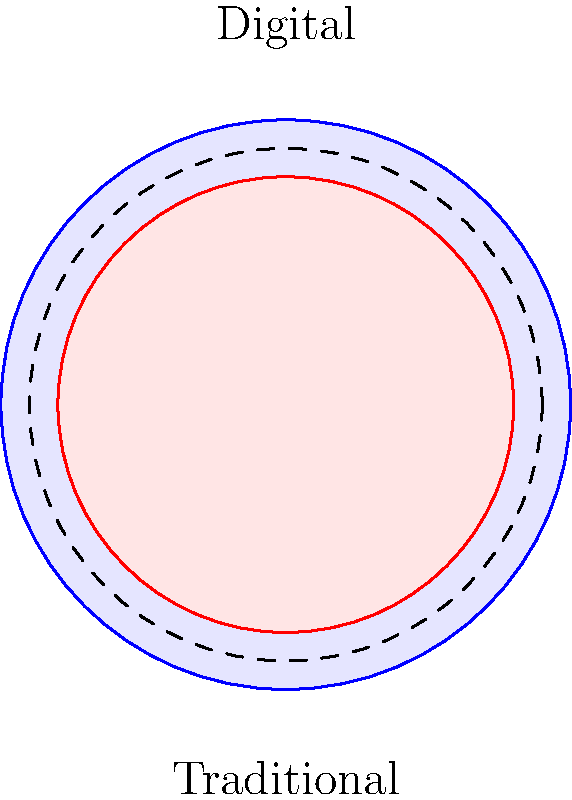Based on the color wheels shown in the diagram, which represents a larger color gamut: digital displays or traditional paint pigments? Explain the significance of this difference for digital artists. To answer this question, let's analyze the diagram and consider the implications for digital artists:

1. Observe the diagram: There are two concentric circles representing color wheels.
   - The outer, larger circle (blue outline) represents the digital color gamut.
   - The inner, smaller circle (red outline) represents the traditional paint pigment color gamut.

2. Compare the sizes:
   - The digital color wheel is noticeably larger than the traditional one.
   - This size difference represents the range of colors that can be produced by each medium.

3. Interpret the difference:
   - A larger color wheel indicates a wider range of colors that can be represented.
   - The digital color gamut extends beyond the traditional paint pigment gamut in all directions.

4. Significance for digital artists:
   - Wider color gamut means more colors are available for use in digital art.
   - Digital artists can create images with colors that may not be achievable using traditional paint pigments.
   - This expanded range allows for more vibrant, saturated, and diverse color palettes in digital artwork.

5. Advantages for digital artists:
   - Greater creative freedom in color selection and manipulation.
   - Ability to represent a broader spectrum of real-world colors accurately.
   - Potential to create visual effects that may be difficult or impossible with traditional media.

6. Implications for art recognition:
   - The larger color gamut supports the argument that digital art is a legitimate and advanced form of artistic expression.
   - It demonstrates that digital art can potentially surpass traditional media in terms of color representation.

In conclusion, the diagram shows that digital displays offer a larger color gamut compared to traditional paint pigments, providing digital artists with a broader range of colors and supporting the legitimacy of digital art as a sophisticated medium.
Answer: Digital displays; larger gamut enables more diverse and vibrant color palettes, supporting digital art's legitimacy and potential. 